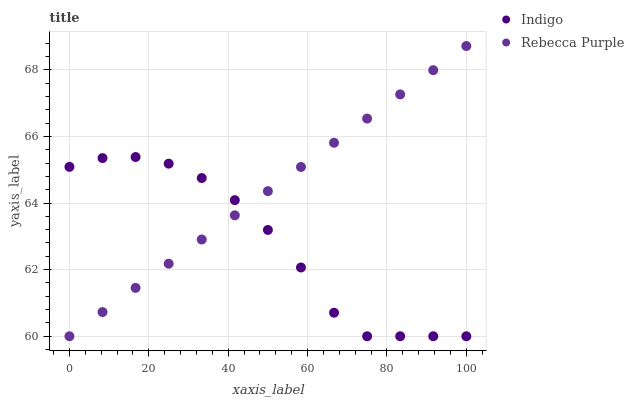Does Indigo have the minimum area under the curve?
Answer yes or no. Yes. Does Rebecca Purple have the maximum area under the curve?
Answer yes or no. Yes. Does Rebecca Purple have the minimum area under the curve?
Answer yes or no. No. Is Rebecca Purple the smoothest?
Answer yes or no. Yes. Is Indigo the roughest?
Answer yes or no. Yes. Is Rebecca Purple the roughest?
Answer yes or no. No. Does Indigo have the lowest value?
Answer yes or no. Yes. Does Rebecca Purple have the highest value?
Answer yes or no. Yes. Does Rebecca Purple intersect Indigo?
Answer yes or no. Yes. Is Rebecca Purple less than Indigo?
Answer yes or no. No. Is Rebecca Purple greater than Indigo?
Answer yes or no. No. 